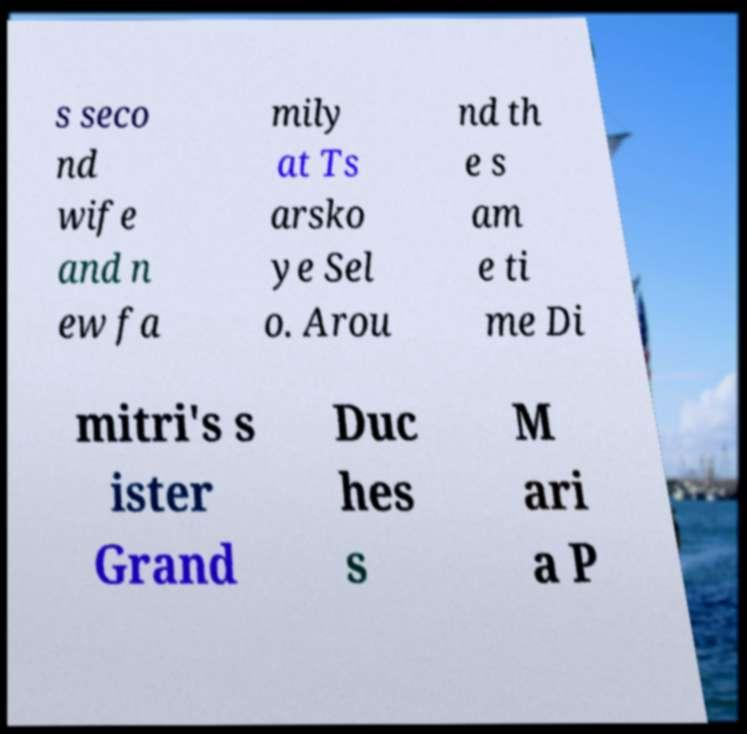I need the written content from this picture converted into text. Can you do that? s seco nd wife and n ew fa mily at Ts arsko ye Sel o. Arou nd th e s am e ti me Di mitri's s ister Grand Duc hes s M ari a P 